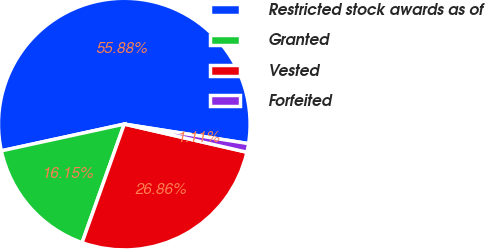<chart> <loc_0><loc_0><loc_500><loc_500><pie_chart><fcel>Restricted stock awards as of<fcel>Granted<fcel>Vested<fcel>Forfeited<nl><fcel>55.89%<fcel>16.15%<fcel>26.86%<fcel>1.11%<nl></chart> 